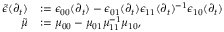Convert formula to latex. <formula><loc_0><loc_0><loc_500><loc_500>\begin{array} { r l } { \widetilde { \epsilon } ( \partial _ { t } ) } & { \mathop \colon = \epsilon _ { 0 0 } ( \partial _ { t } ) - \epsilon _ { 0 1 } ( \partial _ { t } ) \epsilon _ { 1 1 } ( \partial _ { t } ) ^ { - 1 } \epsilon _ { 1 0 } ( \partial _ { t } ) } \\ { \tilde { \mu } } & { \mathop \colon = \mu _ { 0 0 } - \mu _ { 0 1 } \mu _ { 1 1 } ^ { - 1 } \mu _ { 1 0 } , } \end{array}</formula> 